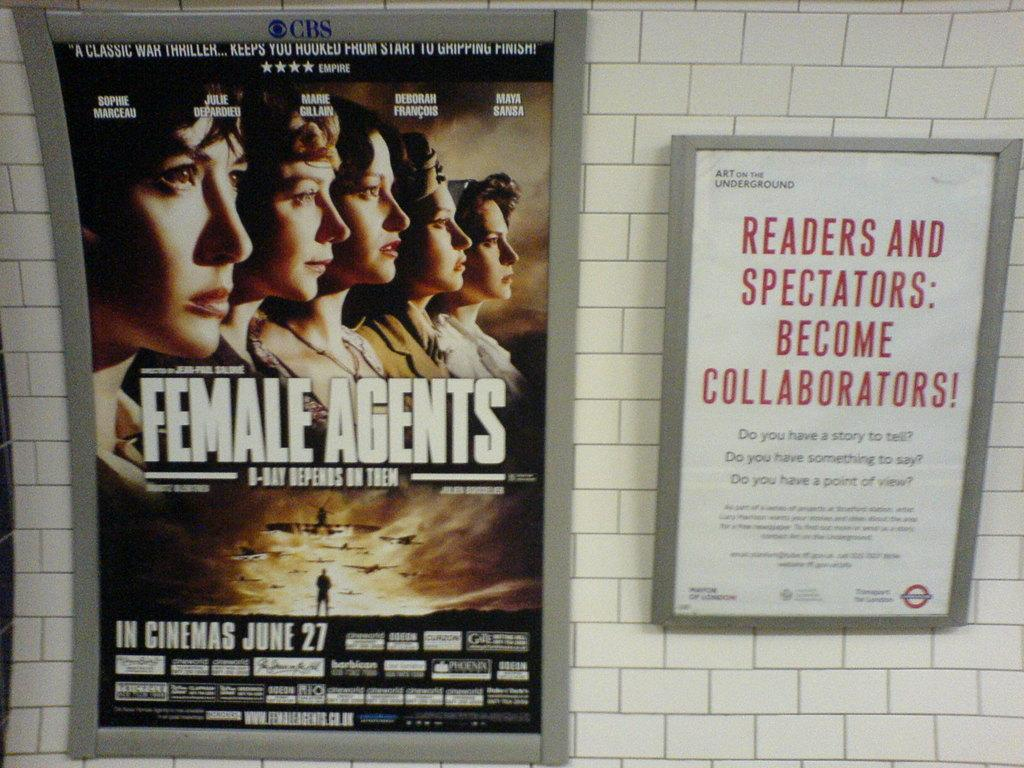<image>
Create a compact narrative representing the image presented. A movie poster for the movie Female Agents which opens June 27th. 